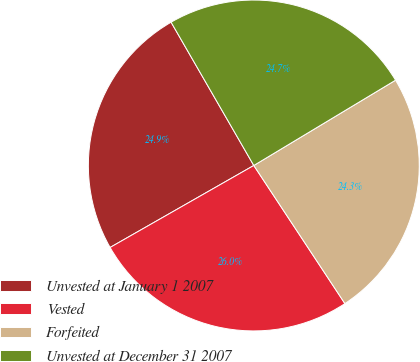Convert chart to OTSL. <chart><loc_0><loc_0><loc_500><loc_500><pie_chart><fcel>Unvested at January 1 2007<fcel>Vested<fcel>Forfeited<fcel>Unvested at December 31 2007<nl><fcel>24.92%<fcel>26.03%<fcel>24.34%<fcel>24.71%<nl></chart> 